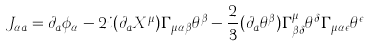<formula> <loc_0><loc_0><loc_500><loc_500>J _ { \alpha a } = \partial _ { a } \phi _ { \alpha } - 2 i ( \partial _ { a } X ^ { \mu } ) \Gamma _ { \mu \alpha \beta } \theta ^ { \beta } - \frac { 2 } { 3 } ( \partial _ { a } \theta ^ { \beta } ) \Gamma _ { \beta \delta } ^ { \mu } \theta ^ { \delta } \Gamma _ { \mu \alpha \epsilon } \theta ^ { \epsilon }</formula> 